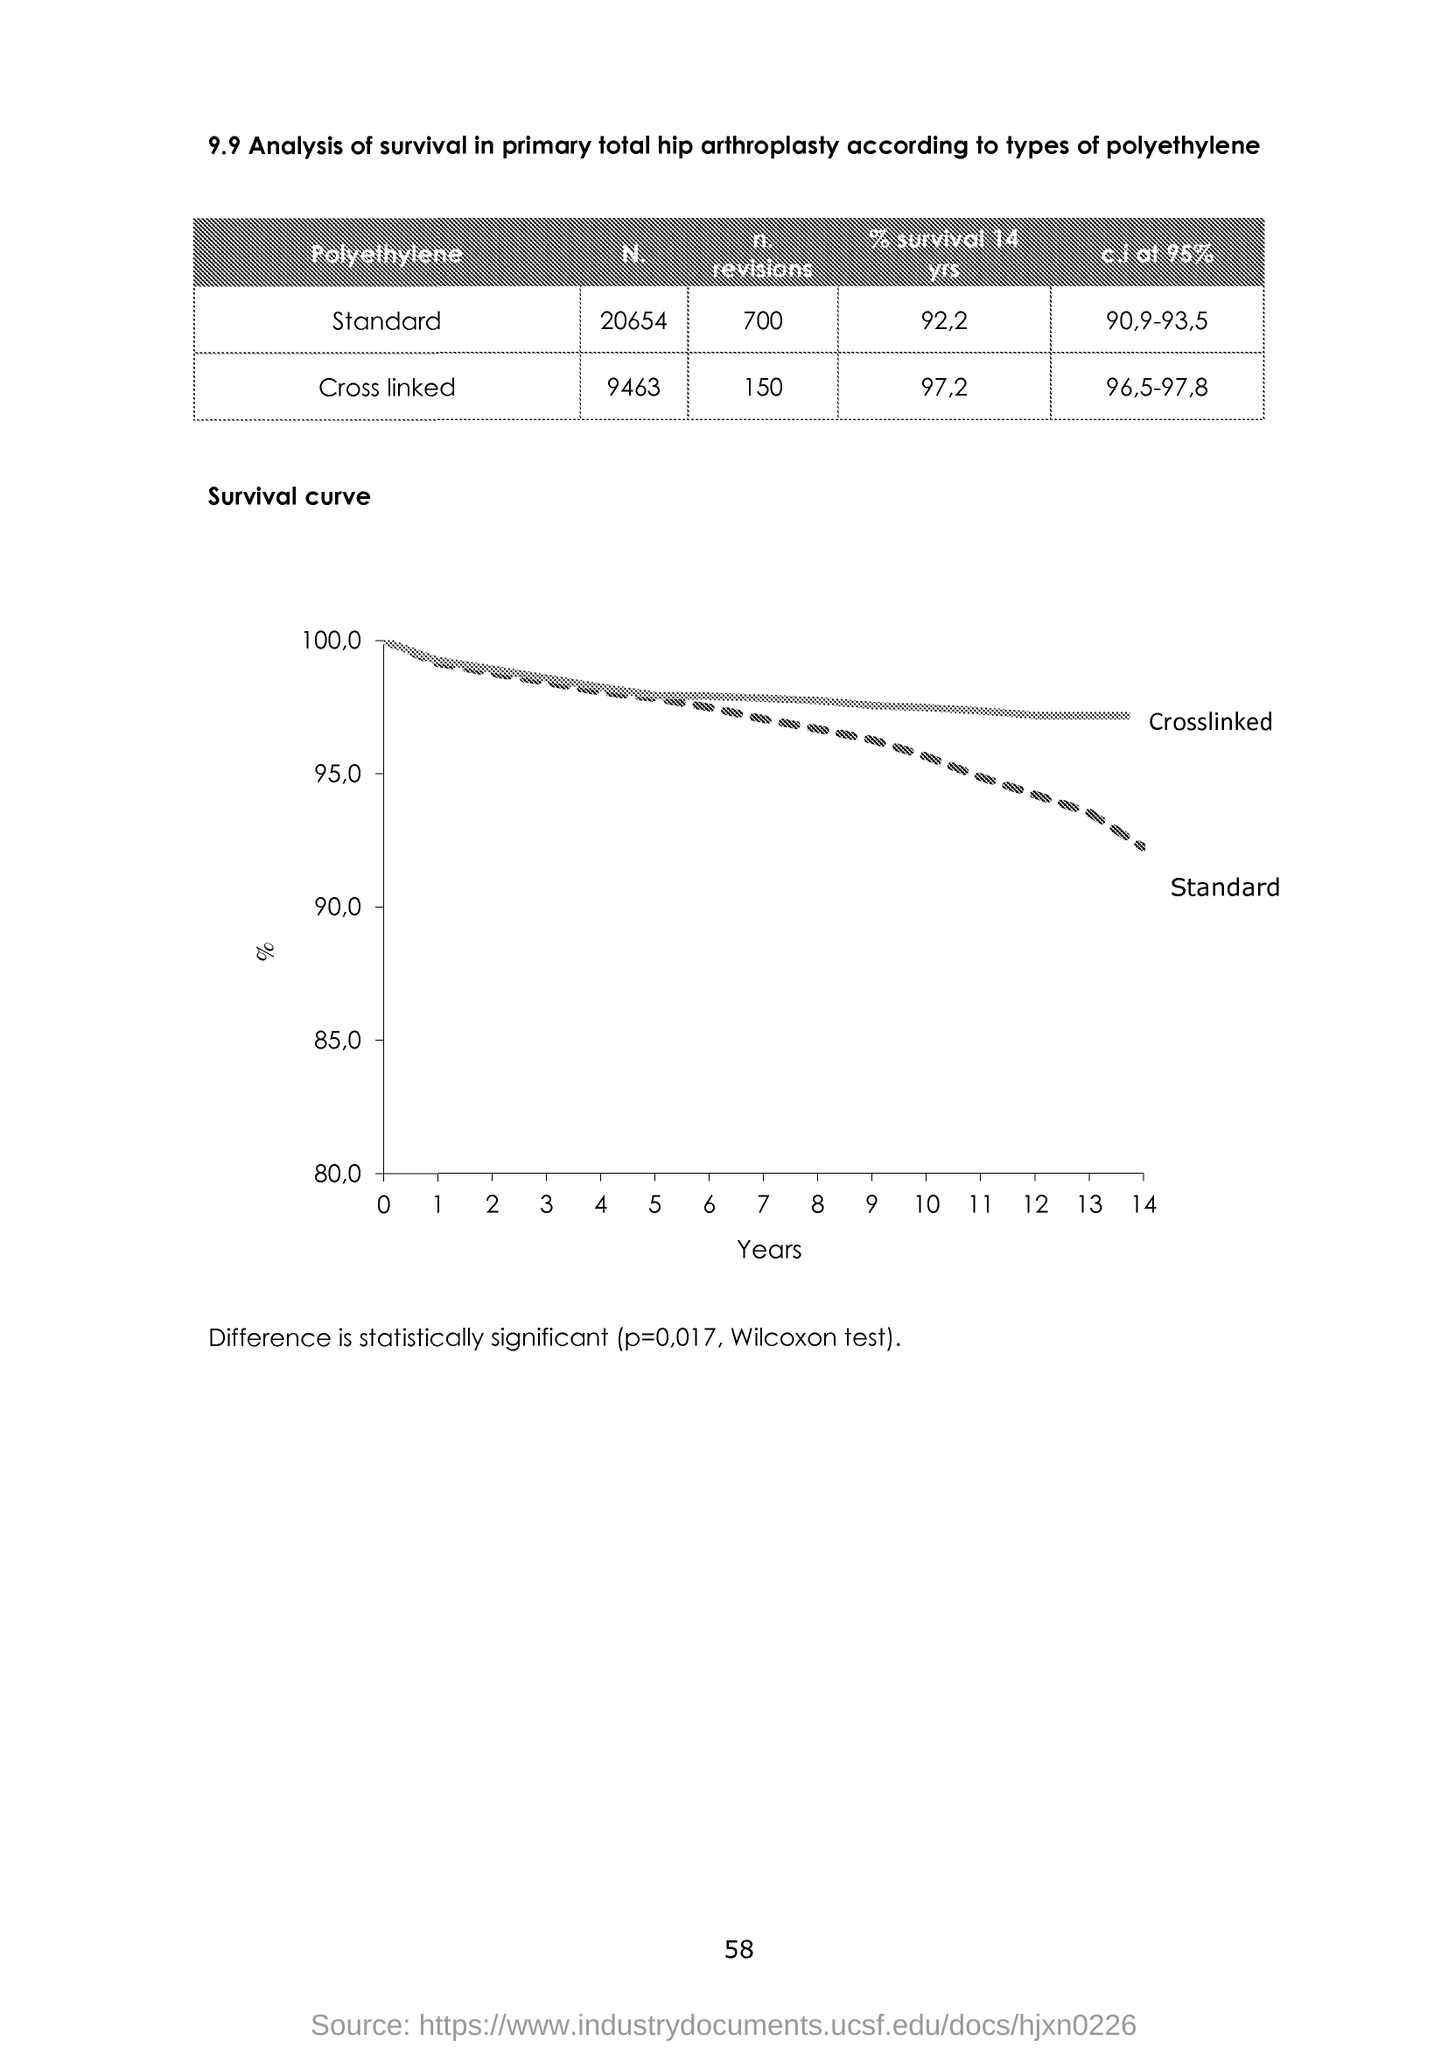What is plotted in the x-axis ?
Give a very brief answer. Years. What is the value of p?
Give a very brief answer. 0.017. 